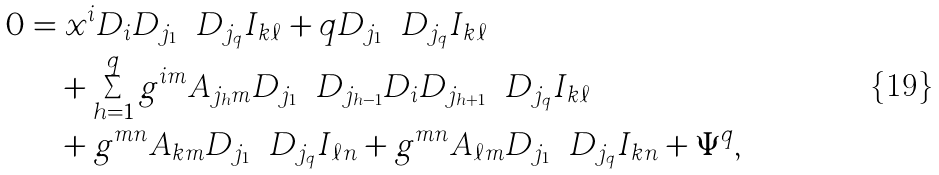<formula> <loc_0><loc_0><loc_500><loc_500>0 & = x ^ { i } D _ { i } D _ { j _ { 1 } } \cdots D _ { j _ { q } } I _ { k \ell } + q D _ { j _ { 1 } } \cdots D _ { j _ { q } } I _ { k \ell } \\ & \quad + \sum ^ { q } _ { h = 1 } g ^ { i m } A _ { j _ { h } m } D _ { j _ { 1 } } \cdots D _ { j _ { h - 1 } } D _ { i } D _ { j _ { h + 1 } } \cdots D _ { j _ { q } } I _ { k \ell } \\ & \quad + g ^ { m n } A _ { k m } D _ { j _ { 1 } } \cdots D _ { j _ { q } } I _ { \ell n } + g ^ { m n } A _ { \ell m } D _ { j _ { 1 } } \cdots D _ { j _ { q } } I _ { k n } + \Psi ^ { q } ,</formula> 